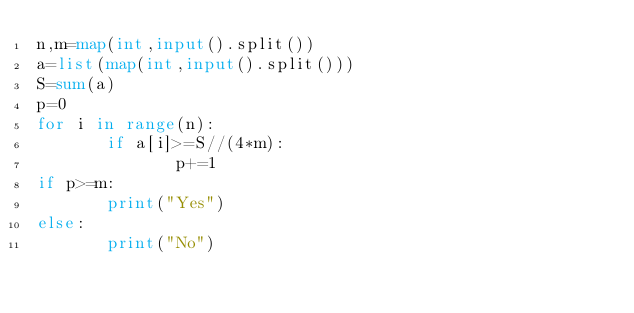Convert code to text. <code><loc_0><loc_0><loc_500><loc_500><_Python_>n,m=map(int,input().split())
a=list(map(int,input().split()))
S=sum(a)
p=0
for i in range(n):
       if a[i]>=S//(4*m):
              p+=1
if p>=m:
       print("Yes")
else:
       print("No")</code> 